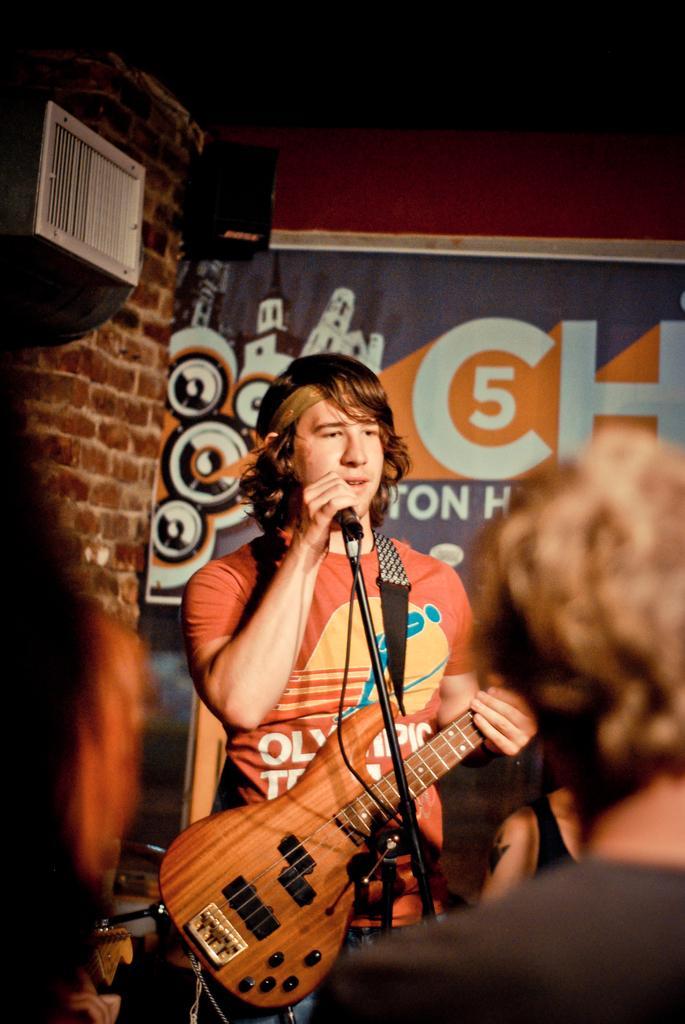Describe this image in one or two sentences. In this image in the center there is one man who is standing and he is holding a guitar in front of him there is one mike it seems that he is singing. On the background there is a wall, on the right side and left side there are two persons. 